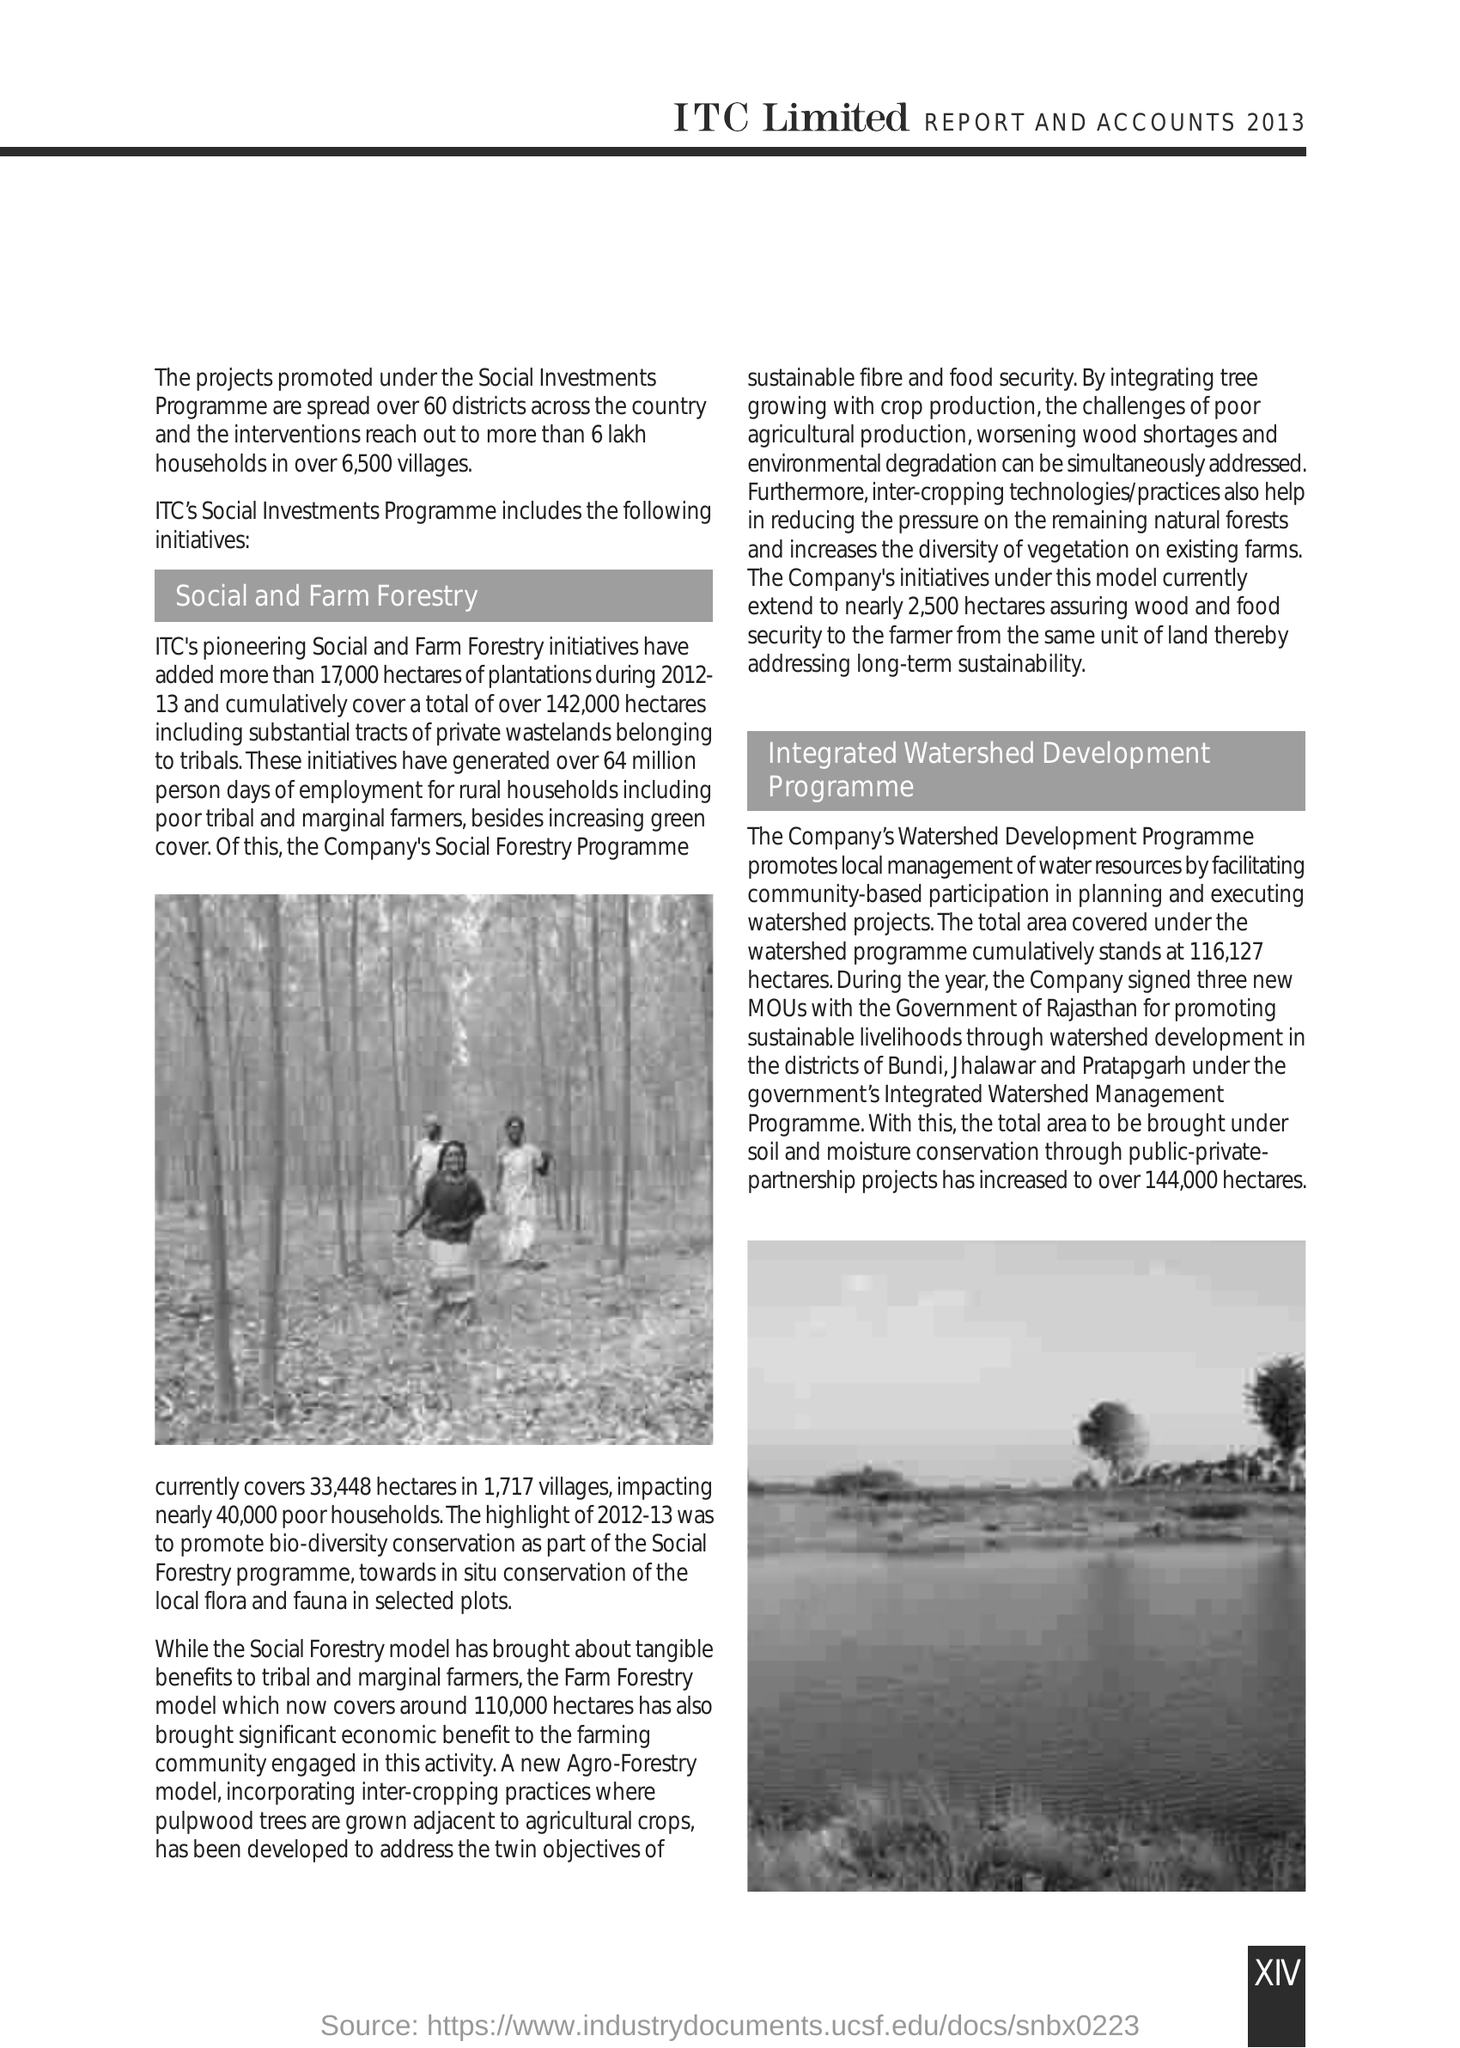Outline some significant characteristics in this image. Our company is dedicated to supporting sustainable practices in the textile industry by promoting the Agro-Forestry model, which addresses the twin objectives of sustainable fibre and food security. The company has entered into agreements with the Government of Rajasthan to collaborate on three different initiatives. The Social Forestry Programme, which is implemented by a company, has a significant impact on nearly 40,000 poor households. The page number given at the right bottom corner of the page is XIV. Under the Social Investments Programme, the promoted projects are currently being implemented in 60 districts across the country. 